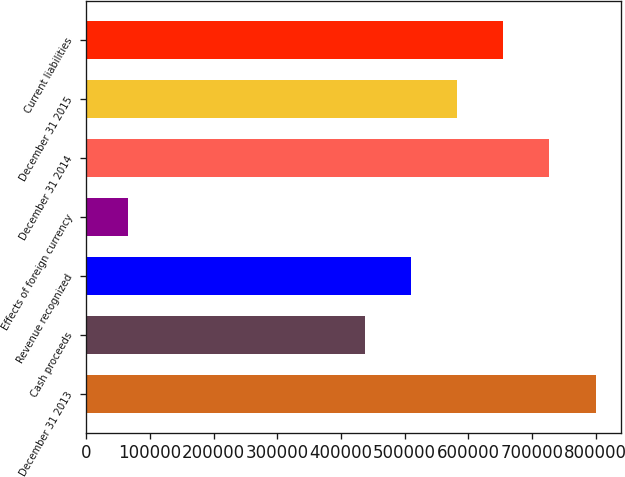Convert chart. <chart><loc_0><loc_0><loc_500><loc_500><bar_chart><fcel>December 31 2013<fcel>Cash proceeds<fcel>Revenue recognized<fcel>Effects of foreign currency<fcel>December 31 2014<fcel>December 31 2015<fcel>Current liabilities<nl><fcel>799842<fcel>437383<fcel>509875<fcel>65637<fcel>727350<fcel>582367<fcel>654858<nl></chart> 